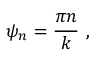Convert formula to latex. <formula><loc_0><loc_0><loc_500><loc_500>\psi _ { n } = { \frac { \pi n } { k } } \ ,</formula> 